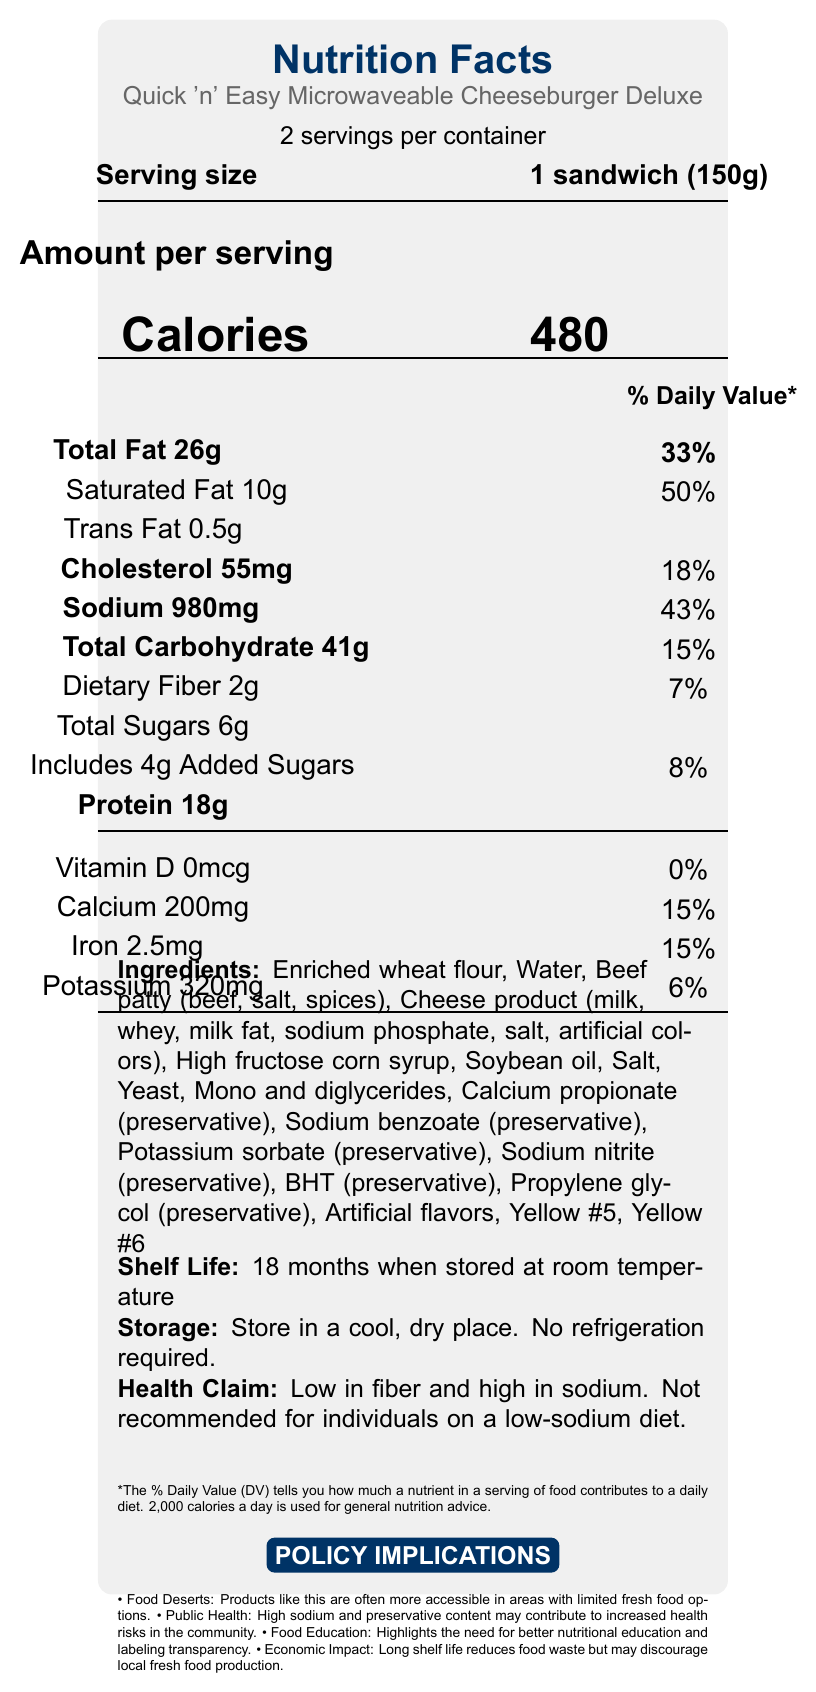what is the serving size for this product? The serving size is clearly stated in the document as "1 sandwich (150g)".
Answer: 1 sandwich (150g) how many servings are in one container? The document notes that there are "2 servings per container".
Answer: 2 what is the total fat content per serving? The document indicates that each serving contains "Total Fat 26g".
Answer: 26g how many grams of protein are in one serving? The document specifies that there are "Protein 18g" per serving.
Answer: 18g what is the percentage of daily value for sodium per serving? The daily value percentage for sodium per serving is provided as "43%".
Answer: 43% What type of meal is this product? A. Salad B. Microwaveable Cheeseburger C. Soup D. Pizza The document explicitly names the product as "Quick 'n' Easy Microwaveable Cheeseburger Deluxe".
Answer: B How much cholesterol is in one serving? A. 55mg B. 100mg C. 75mg D. 30mg The cholesterol content per serving is given as "Cholesterol 55mg".
Answer: A Does this product require refrigeration? The document states "No refrigeration required."
Answer: No Provide a summary of the main health claim mentioned in the document The health claim in the document mentions the product is low in fiber and high in sodium, and not recommended for individuals on a low-sodium diet.
Answer: Low in fiber and high in sodium. Not recommended for individuals on a low-sodium diet. From which country is this product manufactured? There is no information in the document regarding the country of manufacture.
Answer: Not enough information What preservatives are included in the ingredients list? The document lists these preservatives among the ingredients.
Answer: Calcium propionate, Sodium benzoate, Potassium sorbate, Sodium nitrite, BHT, Propylene glycol What is the shelf life of this product? The document notes the shelf life as "18 months when stored at room temperature".
Answer: 18 months when stored at room temperature How does the product impact food deserts? The document suggests that this type of product is more accessible in areas known as food deserts.
Answer: Products like this are often more accessible in areas with limited fresh food options. What is the main policy implication related to public health? The document indicates the high sodium and preservative content as a public health concern.
Answer: High sodium and preservative content may contribute to increased health risks in the community. Is there any Vitamin D in this product? The document clearly shows "Vitamin D 0mcg" which translates to no Vitamin D content.
Answer: No Approximately how many calories would you consume if you ate the entire container? Each serving is 480 calories, and there are 2 servings per container. Thus, 480 calories/serving * 2 servings = 960 calories.
Answer: 960 